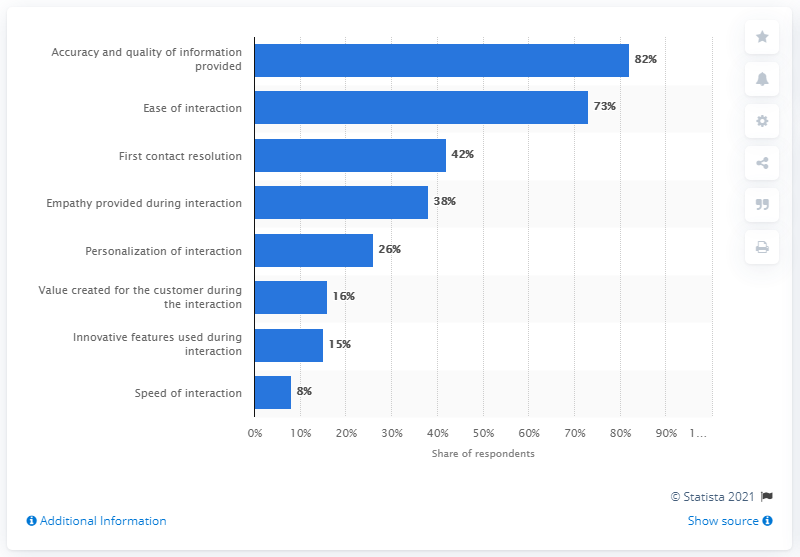Specify some key components in this picture. To find the average, take the largest value and smallest value, and divide them by 2, I performed the following steps:

1. I first found the sum of all the values in the list 45.
2. I then divided the sum by the number of values in the list to find the average.
3. To find the largest value, I found the largest value in the list.
4. To find the smallest value, I found the smallest value in the list. There are two bars that are above 50%. 